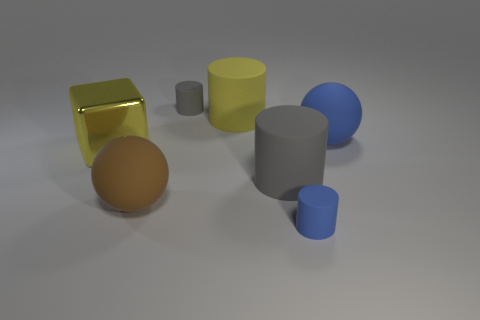There is a small cylinder that is to the right of the yellow cylinder; how many small cylinders are behind it?
Provide a short and direct response. 1. Does the yellow thing that is on the right side of the tiny gray thing have the same material as the large blue object?
Keep it short and to the point. Yes. Is there anything else that is made of the same material as the big yellow cube?
Your answer should be very brief. No. There is a sphere that is on the left side of the small cylinder that is left of the yellow rubber object; what size is it?
Keep it short and to the point. Large. There is a rubber cylinder behind the yellow object to the right of the big yellow thing on the left side of the brown sphere; how big is it?
Give a very brief answer. Small. Do the small matte thing that is on the left side of the large yellow matte cylinder and the yellow object that is to the left of the brown object have the same shape?
Give a very brief answer. No. How many other things are there of the same color as the shiny object?
Offer a very short reply. 1. There is a gray rubber cylinder that is in front of the metallic cube; is its size the same as the tiny blue object?
Your response must be concise. No. Are the big yellow thing that is behind the big blue ball and the gray thing in front of the large yellow metallic thing made of the same material?
Provide a succinct answer. Yes. Is there a green ball of the same size as the yellow rubber cylinder?
Provide a succinct answer. No. 